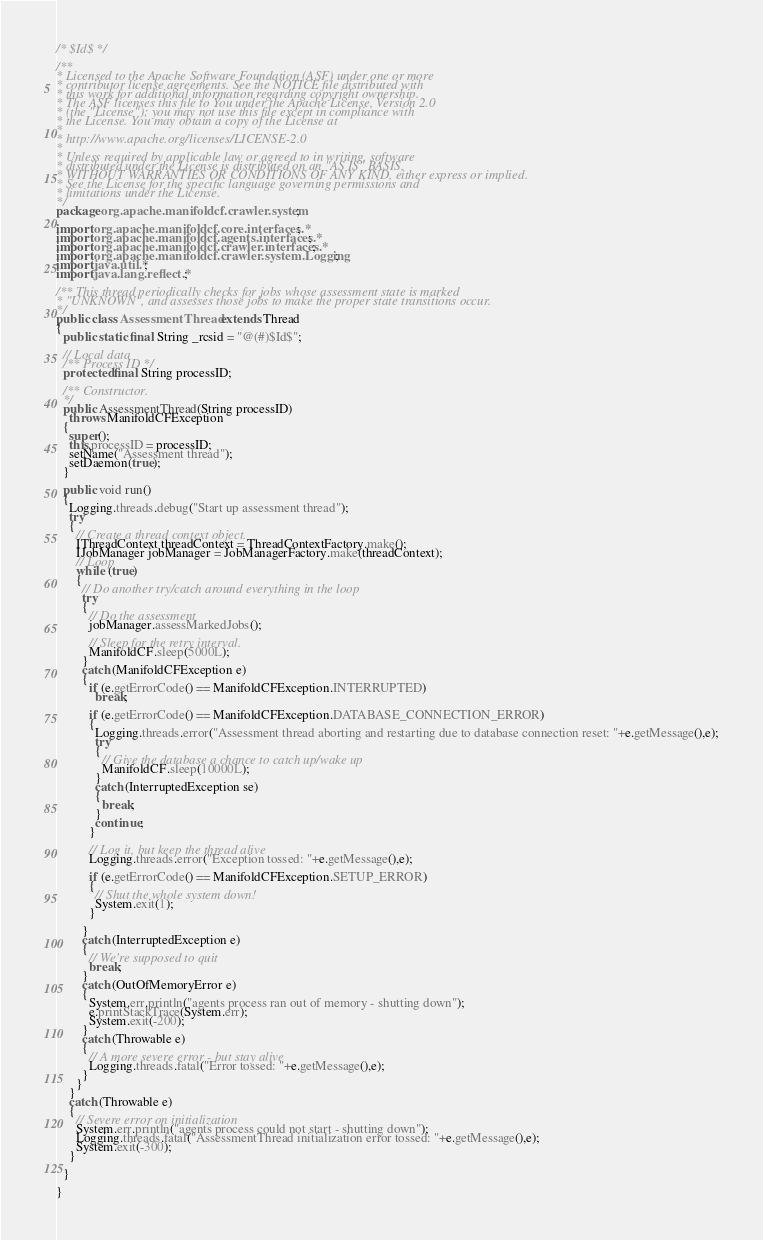Convert code to text. <code><loc_0><loc_0><loc_500><loc_500><_Java_>/* $Id$ */

/**
* Licensed to the Apache Software Foundation (ASF) under one or more
* contributor license agreements. See the NOTICE file distributed with
* this work for additional information regarding copyright ownership.
* The ASF licenses this file to You under the Apache License, Version 2.0
* (the "License"); you may not use this file except in compliance with
* the License. You may obtain a copy of the License at
*
* http://www.apache.org/licenses/LICENSE-2.0
*
* Unless required by applicable law or agreed to in writing, software
* distributed under the License is distributed on an "AS IS" BASIS,
* WITHOUT WARRANTIES OR CONDITIONS OF ANY KIND, either express or implied.
* See the License for the specific language governing permissions and
* limitations under the License.
*/
package org.apache.manifoldcf.crawler.system;

import org.apache.manifoldcf.core.interfaces.*;
import org.apache.manifoldcf.agents.interfaces.*;
import org.apache.manifoldcf.crawler.interfaces.*;
import org.apache.manifoldcf.crawler.system.Logging;
import java.util.*;
import java.lang.reflect.*;

/** This thread periodically checks for jobs whose assessment state is marked
* "UNKNOWN", and assesses those jobs to make the proper state transitions occur.
*/
public class AssessmentThread extends Thread
{
  public static final String _rcsid = "@(#)$Id$";

  // Local data
  /** Process ID */
  protected final String processID;

  /** Constructor.
  */
  public AssessmentThread(String processID)
    throws ManifoldCFException
  {
    super();
    this.processID = processID;
    setName("Assessment thread");
    setDaemon(true);
  }

  public void run()
  {
    Logging.threads.debug("Start up assessment thread");
    try
    {
      // Create a thread context object.
      IThreadContext threadContext = ThreadContextFactory.make();
      IJobManager jobManager = JobManagerFactory.make(threadContext);
      // Loop
      while (true)
      {
        // Do another try/catch around everything in the loop
        try
        {
          // Do the assessment
          jobManager.assessMarkedJobs();
          
          // Sleep for the retry interval.
          ManifoldCF.sleep(5000L);
        }
        catch (ManifoldCFException e)
        {
          if (e.getErrorCode() == ManifoldCFException.INTERRUPTED)
            break;

          if (e.getErrorCode() == ManifoldCFException.DATABASE_CONNECTION_ERROR)
          {
            Logging.threads.error("Assessment thread aborting and restarting due to database connection reset: "+e.getMessage(),e);
            try
            {
              // Give the database a chance to catch up/wake up
              ManifoldCF.sleep(10000L);
            }
            catch (InterruptedException se)
            {
              break;
            }
            continue;
          }

          // Log it, but keep the thread alive
          Logging.threads.error("Exception tossed: "+e.getMessage(),e);

          if (e.getErrorCode() == ManifoldCFException.SETUP_ERROR)
          {
            // Shut the whole system down!
            System.exit(1);
          }

        }
        catch (InterruptedException e)
        {
          // We're supposed to quit
          break;
        }
        catch (OutOfMemoryError e)
        {
          System.err.println("agents process ran out of memory - shutting down");
          e.printStackTrace(System.err);
          System.exit(-200);
        }
        catch (Throwable e)
        {
          // A more severe error - but stay alive
          Logging.threads.fatal("Error tossed: "+e.getMessage(),e);
        }
      }
    }
    catch (Throwable e)
    {
      // Severe error on initialization
      System.err.println("agents process could not start - shutting down");
      Logging.threads.fatal("AssessmentThread initialization error tossed: "+e.getMessage(),e);
      System.exit(-300);
    }

  }

}
</code> 